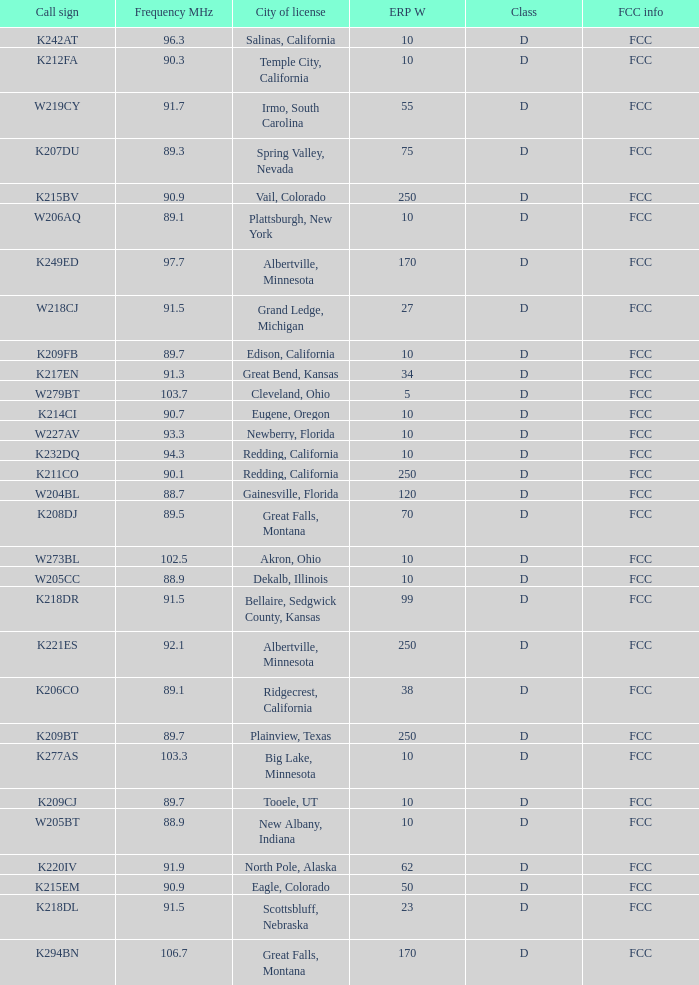What is the FCC info of the translator with an Irmo, South Carolina city license? FCC. 